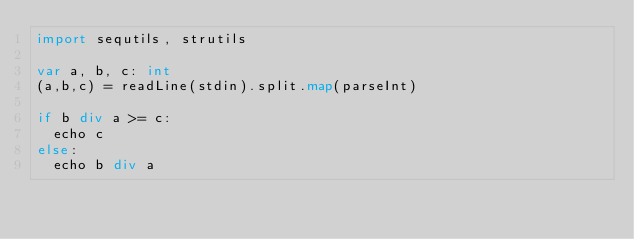<code> <loc_0><loc_0><loc_500><loc_500><_Nim_>import sequtils, strutils

var a, b, c: int
(a,b,c) = readLine(stdin).split.map(parseInt)

if b div a >= c:
  echo c
else:
  echo b div a</code> 